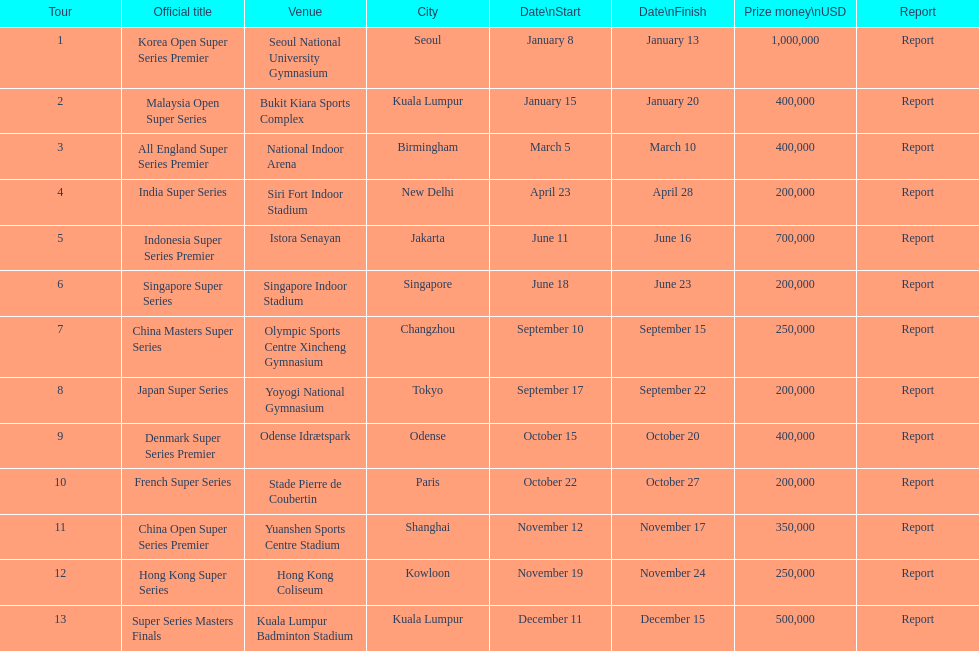In which series is the top prize amount the highest? Korea Open Super Series Premier. 